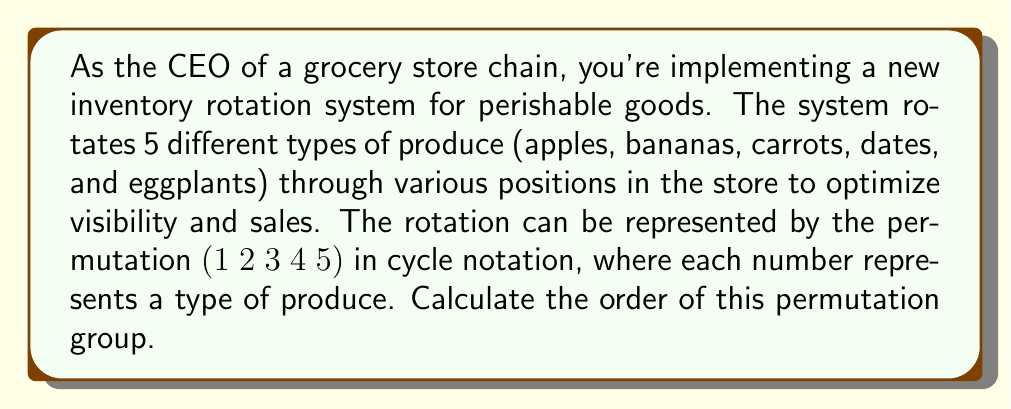Solve this math problem. To solve this problem, we need to understand the concept of order in permutation groups:

1. The order of a permutation is the smallest positive integer $n$ such that $\sigma^n = e$, where $\sigma$ is the permutation and $e$ is the identity permutation.

2. For a cycle, the order is equal to the length of the cycle.

3. In this case, we have the permutation $\sigma = (1\;2\;3\;4\;5)$, which is a single cycle of length 5.

4. Let's verify this by applying the permutation repeatedly:
   
   $\sigma^1 = (1\;2\;3\;4\;5)$
   $\sigma^2 = (1\;3\;5\;2\;4)$
   $\sigma^3 = (1\;4\;2\;5\;3)$
   $\sigma^4 = (1\;5\;4\;3\;2)$
   $\sigma^5 = (1)(2)(3)(4)(5) = e$

5. We can see that it takes 5 applications of the permutation to return to the identity permutation.

Therefore, the order of this permutation group is 5.

This means that after 5 complete rotations, all produce items will return to their original positions in the store layout.
Answer: The order of the permutation group is 5. 